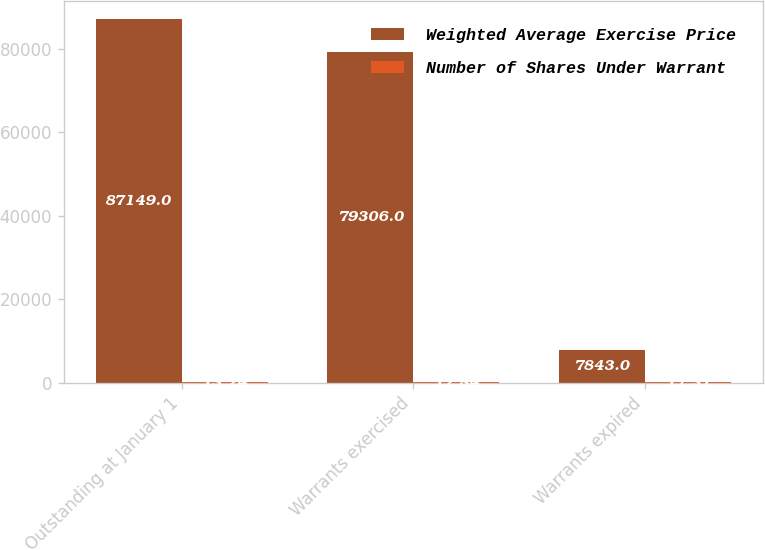Convert chart. <chart><loc_0><loc_0><loc_500><loc_500><stacked_bar_chart><ecel><fcel>Outstanding at January 1<fcel>Warrants exercised<fcel>Warrants expired<nl><fcel>Weighted Average Exercise Price<fcel>87149<fcel>79306<fcel>7843<nl><fcel>Number of Shares Under Warrant<fcel>13.24<fcel>12.84<fcel>17.31<nl></chart> 